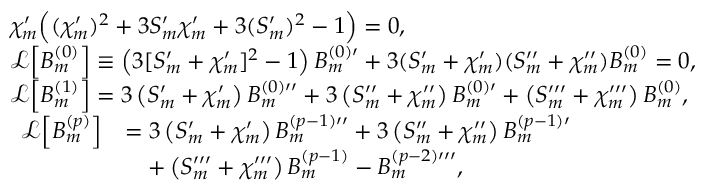<formula> <loc_0><loc_0><loc_500><loc_500>\begin{array} { r l } & { { \chi } _ { m } ^ { \prime } \left ( ( { \chi } _ { m } ^ { \prime } ) ^ { 2 } + 3 S _ { m } ^ { \prime } { \chi } _ { m } ^ { \prime } + 3 ( S _ { m } ^ { \prime } ) ^ { 2 } - 1 \right ) = 0 , } \\ & { \mathcal { L } \left [ B _ { m } ^ { ( 0 ) } \right ] \equiv \left ( 3 [ S _ { m } ^ { \prime } + \chi _ { m } ^ { \prime } ] ^ { 2 } - 1 \right ) B _ { m } ^ { ( 0 ) \prime } + 3 ( S _ { m } ^ { \prime } + \chi _ { m } ^ { \prime } ) ( S _ { m } ^ { \prime \prime } + \chi _ { m } ^ { \prime \prime } ) B _ { m } ^ { ( 0 ) } = 0 , } \\ & { \mathcal { L } \left [ B _ { m } ^ { ( 1 ) } \right ] = 3 \left ( S _ { m } ^ { \prime } + \chi _ { m } ^ { \prime } \right ) B _ { m } ^ { ( 0 ) \prime \prime } + 3 \left ( S _ { m } ^ { \prime \prime } + \chi _ { m } ^ { \prime \prime } \right ) B _ { m } ^ { ( 0 ) \prime } + \left ( S _ { m } ^ { \prime \prime \prime } + \chi _ { m } ^ { \prime \prime \prime } \right ) B _ { m } ^ { ( 0 ) } , } \\ & { \begin{array} { r l } { \mathcal { L } \left [ B _ { m } ^ { ( p ) } \right ] } & { = 3 \left ( S _ { m } ^ { \prime } + \chi _ { m } ^ { \prime } \right ) B _ { m } ^ { ( p - 1 ) \prime \prime } + 3 \left ( S _ { m } ^ { \prime \prime } + \chi _ { m } ^ { \prime \prime } \right ) B _ { m } ^ { ( p - 1 ) \prime } } \\ & { \quad + \left ( S _ { m } ^ { \prime \prime \prime } + \chi _ { m } ^ { \prime \prime \prime } \right ) B _ { m } ^ { ( p - 1 ) } - B _ { m } ^ { ( p - 2 ) \prime \prime \prime } , } \end{array} } \end{array}</formula> 